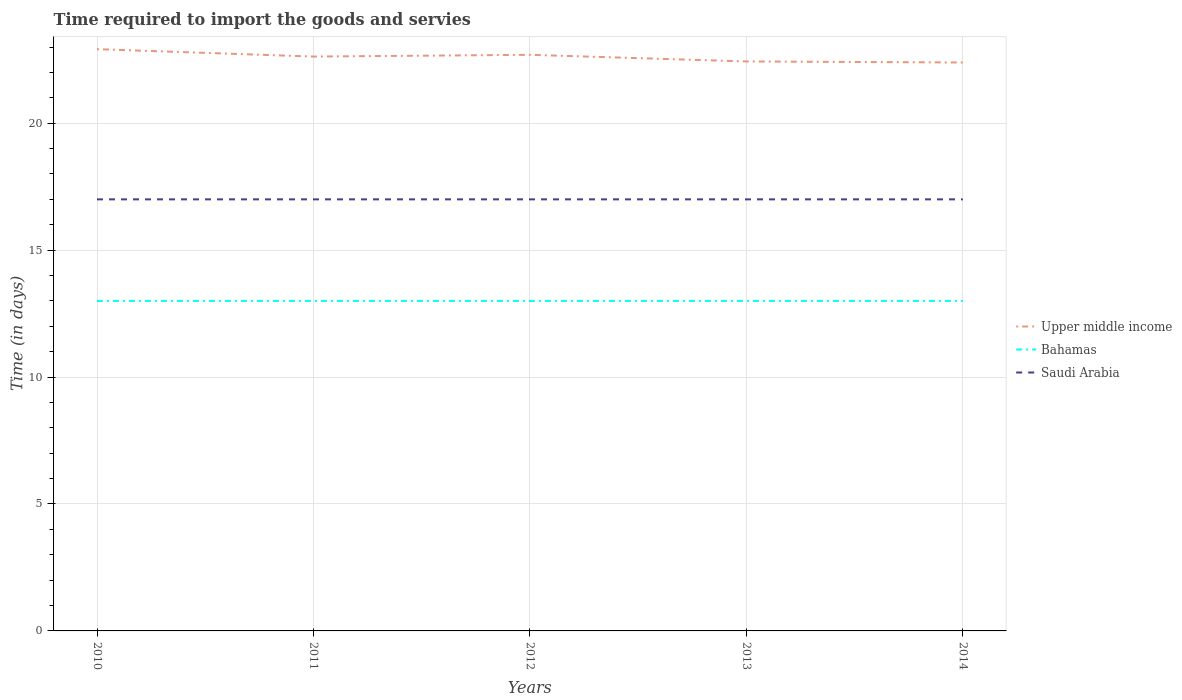Across all years, what is the maximum number of days required to import the goods and services in Upper middle income?
Your answer should be compact. 22.39. In which year was the number of days required to import the goods and services in Upper middle income maximum?
Provide a short and direct response. 2014. What is the difference between the highest and the lowest number of days required to import the goods and services in Saudi Arabia?
Offer a very short reply. 0. Does the graph contain grids?
Keep it short and to the point. Yes. Where does the legend appear in the graph?
Keep it short and to the point. Center right. How many legend labels are there?
Provide a succinct answer. 3. How are the legend labels stacked?
Offer a terse response. Vertical. What is the title of the graph?
Provide a short and direct response. Time required to import the goods and servies. Does "United Kingdom" appear as one of the legend labels in the graph?
Make the answer very short. No. What is the label or title of the Y-axis?
Make the answer very short. Time (in days). What is the Time (in days) of Upper middle income in 2010?
Provide a succinct answer. 22.92. What is the Time (in days) in Upper middle income in 2011?
Offer a very short reply. 22.62. What is the Time (in days) of Bahamas in 2011?
Keep it short and to the point. 13. What is the Time (in days) in Saudi Arabia in 2011?
Provide a succinct answer. 17. What is the Time (in days) of Upper middle income in 2012?
Provide a succinct answer. 22.69. What is the Time (in days) of Bahamas in 2012?
Offer a very short reply. 13. What is the Time (in days) in Saudi Arabia in 2012?
Give a very brief answer. 17. What is the Time (in days) in Upper middle income in 2013?
Keep it short and to the point. 22.43. What is the Time (in days) of Upper middle income in 2014?
Offer a terse response. 22.39. What is the Time (in days) of Saudi Arabia in 2014?
Give a very brief answer. 17. Across all years, what is the maximum Time (in days) in Upper middle income?
Give a very brief answer. 22.92. Across all years, what is the minimum Time (in days) in Upper middle income?
Your answer should be very brief. 22.39. Across all years, what is the minimum Time (in days) in Bahamas?
Provide a short and direct response. 13. Across all years, what is the minimum Time (in days) of Saudi Arabia?
Provide a short and direct response. 17. What is the total Time (in days) of Upper middle income in the graph?
Your response must be concise. 113.06. What is the difference between the Time (in days) of Upper middle income in 2010 and that in 2011?
Offer a terse response. 0.29. What is the difference between the Time (in days) in Saudi Arabia in 2010 and that in 2011?
Give a very brief answer. 0. What is the difference between the Time (in days) in Upper middle income in 2010 and that in 2012?
Your response must be concise. 0.22. What is the difference between the Time (in days) of Bahamas in 2010 and that in 2012?
Provide a short and direct response. 0. What is the difference between the Time (in days) in Saudi Arabia in 2010 and that in 2012?
Provide a short and direct response. 0. What is the difference between the Time (in days) in Upper middle income in 2010 and that in 2013?
Offer a terse response. 0.48. What is the difference between the Time (in days) in Bahamas in 2010 and that in 2013?
Your answer should be compact. 0. What is the difference between the Time (in days) in Saudi Arabia in 2010 and that in 2013?
Provide a short and direct response. 0. What is the difference between the Time (in days) of Upper middle income in 2010 and that in 2014?
Your response must be concise. 0.52. What is the difference between the Time (in days) in Bahamas in 2010 and that in 2014?
Offer a terse response. 0. What is the difference between the Time (in days) of Saudi Arabia in 2010 and that in 2014?
Make the answer very short. 0. What is the difference between the Time (in days) in Upper middle income in 2011 and that in 2012?
Provide a succinct answer. -0.07. What is the difference between the Time (in days) in Upper middle income in 2011 and that in 2013?
Keep it short and to the point. 0.19. What is the difference between the Time (in days) in Bahamas in 2011 and that in 2013?
Provide a succinct answer. 0. What is the difference between the Time (in days) of Upper middle income in 2011 and that in 2014?
Keep it short and to the point. 0.23. What is the difference between the Time (in days) of Saudi Arabia in 2011 and that in 2014?
Your answer should be compact. 0. What is the difference between the Time (in days) in Upper middle income in 2012 and that in 2013?
Ensure brevity in your answer.  0.26. What is the difference between the Time (in days) of Upper middle income in 2012 and that in 2014?
Offer a very short reply. 0.3. What is the difference between the Time (in days) of Bahamas in 2012 and that in 2014?
Make the answer very short. 0. What is the difference between the Time (in days) in Saudi Arabia in 2012 and that in 2014?
Make the answer very short. 0. What is the difference between the Time (in days) in Upper middle income in 2013 and that in 2014?
Your answer should be compact. 0.04. What is the difference between the Time (in days) in Bahamas in 2013 and that in 2014?
Ensure brevity in your answer.  0. What is the difference between the Time (in days) in Saudi Arabia in 2013 and that in 2014?
Ensure brevity in your answer.  0. What is the difference between the Time (in days) of Upper middle income in 2010 and the Time (in days) of Bahamas in 2011?
Give a very brief answer. 9.92. What is the difference between the Time (in days) of Upper middle income in 2010 and the Time (in days) of Saudi Arabia in 2011?
Your response must be concise. 5.92. What is the difference between the Time (in days) in Upper middle income in 2010 and the Time (in days) in Bahamas in 2012?
Offer a terse response. 9.92. What is the difference between the Time (in days) of Upper middle income in 2010 and the Time (in days) of Saudi Arabia in 2012?
Give a very brief answer. 5.92. What is the difference between the Time (in days) in Bahamas in 2010 and the Time (in days) in Saudi Arabia in 2012?
Make the answer very short. -4. What is the difference between the Time (in days) of Upper middle income in 2010 and the Time (in days) of Bahamas in 2013?
Your answer should be compact. 9.92. What is the difference between the Time (in days) of Upper middle income in 2010 and the Time (in days) of Saudi Arabia in 2013?
Your response must be concise. 5.92. What is the difference between the Time (in days) in Bahamas in 2010 and the Time (in days) in Saudi Arabia in 2013?
Offer a very short reply. -4. What is the difference between the Time (in days) in Upper middle income in 2010 and the Time (in days) in Bahamas in 2014?
Your answer should be compact. 9.92. What is the difference between the Time (in days) of Upper middle income in 2010 and the Time (in days) of Saudi Arabia in 2014?
Ensure brevity in your answer.  5.92. What is the difference between the Time (in days) of Upper middle income in 2011 and the Time (in days) of Bahamas in 2012?
Your answer should be compact. 9.62. What is the difference between the Time (in days) of Upper middle income in 2011 and the Time (in days) of Saudi Arabia in 2012?
Keep it short and to the point. 5.62. What is the difference between the Time (in days) of Upper middle income in 2011 and the Time (in days) of Bahamas in 2013?
Offer a terse response. 9.62. What is the difference between the Time (in days) of Upper middle income in 2011 and the Time (in days) of Saudi Arabia in 2013?
Your answer should be very brief. 5.62. What is the difference between the Time (in days) of Upper middle income in 2011 and the Time (in days) of Bahamas in 2014?
Provide a succinct answer. 9.62. What is the difference between the Time (in days) in Upper middle income in 2011 and the Time (in days) in Saudi Arabia in 2014?
Ensure brevity in your answer.  5.62. What is the difference between the Time (in days) of Bahamas in 2011 and the Time (in days) of Saudi Arabia in 2014?
Give a very brief answer. -4. What is the difference between the Time (in days) of Upper middle income in 2012 and the Time (in days) of Bahamas in 2013?
Give a very brief answer. 9.69. What is the difference between the Time (in days) of Upper middle income in 2012 and the Time (in days) of Saudi Arabia in 2013?
Ensure brevity in your answer.  5.69. What is the difference between the Time (in days) in Bahamas in 2012 and the Time (in days) in Saudi Arabia in 2013?
Offer a very short reply. -4. What is the difference between the Time (in days) in Upper middle income in 2012 and the Time (in days) in Bahamas in 2014?
Provide a succinct answer. 9.69. What is the difference between the Time (in days) of Upper middle income in 2012 and the Time (in days) of Saudi Arabia in 2014?
Your response must be concise. 5.69. What is the difference between the Time (in days) in Upper middle income in 2013 and the Time (in days) in Bahamas in 2014?
Offer a terse response. 9.43. What is the difference between the Time (in days) of Upper middle income in 2013 and the Time (in days) of Saudi Arabia in 2014?
Your response must be concise. 5.43. What is the average Time (in days) in Upper middle income per year?
Your response must be concise. 22.61. In the year 2010, what is the difference between the Time (in days) of Upper middle income and Time (in days) of Bahamas?
Provide a short and direct response. 9.92. In the year 2010, what is the difference between the Time (in days) of Upper middle income and Time (in days) of Saudi Arabia?
Provide a succinct answer. 5.92. In the year 2011, what is the difference between the Time (in days) in Upper middle income and Time (in days) in Bahamas?
Provide a succinct answer. 9.62. In the year 2011, what is the difference between the Time (in days) in Upper middle income and Time (in days) in Saudi Arabia?
Keep it short and to the point. 5.62. In the year 2012, what is the difference between the Time (in days) of Upper middle income and Time (in days) of Bahamas?
Offer a terse response. 9.69. In the year 2012, what is the difference between the Time (in days) in Upper middle income and Time (in days) in Saudi Arabia?
Provide a succinct answer. 5.69. In the year 2013, what is the difference between the Time (in days) in Upper middle income and Time (in days) in Bahamas?
Your answer should be compact. 9.43. In the year 2013, what is the difference between the Time (in days) in Upper middle income and Time (in days) in Saudi Arabia?
Make the answer very short. 5.43. In the year 2014, what is the difference between the Time (in days) in Upper middle income and Time (in days) in Bahamas?
Your answer should be compact. 9.39. In the year 2014, what is the difference between the Time (in days) of Upper middle income and Time (in days) of Saudi Arabia?
Give a very brief answer. 5.39. In the year 2014, what is the difference between the Time (in days) in Bahamas and Time (in days) in Saudi Arabia?
Provide a succinct answer. -4. What is the ratio of the Time (in days) in Upper middle income in 2010 to that in 2011?
Keep it short and to the point. 1.01. What is the ratio of the Time (in days) in Upper middle income in 2010 to that in 2012?
Offer a very short reply. 1.01. What is the ratio of the Time (in days) in Saudi Arabia in 2010 to that in 2012?
Make the answer very short. 1. What is the ratio of the Time (in days) of Upper middle income in 2010 to that in 2013?
Offer a very short reply. 1.02. What is the ratio of the Time (in days) in Upper middle income in 2010 to that in 2014?
Your answer should be compact. 1.02. What is the ratio of the Time (in days) in Bahamas in 2010 to that in 2014?
Keep it short and to the point. 1. What is the ratio of the Time (in days) in Saudi Arabia in 2010 to that in 2014?
Your response must be concise. 1. What is the ratio of the Time (in days) of Upper middle income in 2011 to that in 2013?
Your response must be concise. 1.01. What is the ratio of the Time (in days) in Upper middle income in 2011 to that in 2014?
Ensure brevity in your answer.  1.01. What is the ratio of the Time (in days) in Bahamas in 2011 to that in 2014?
Keep it short and to the point. 1. What is the ratio of the Time (in days) in Saudi Arabia in 2011 to that in 2014?
Offer a very short reply. 1. What is the ratio of the Time (in days) in Upper middle income in 2012 to that in 2013?
Offer a very short reply. 1.01. What is the ratio of the Time (in days) of Upper middle income in 2012 to that in 2014?
Offer a terse response. 1.01. What is the ratio of the Time (in days) in Bahamas in 2012 to that in 2014?
Your answer should be very brief. 1. What is the ratio of the Time (in days) in Upper middle income in 2013 to that in 2014?
Offer a very short reply. 1. What is the ratio of the Time (in days) of Saudi Arabia in 2013 to that in 2014?
Give a very brief answer. 1. What is the difference between the highest and the second highest Time (in days) in Upper middle income?
Provide a succinct answer. 0.22. What is the difference between the highest and the second highest Time (in days) in Bahamas?
Ensure brevity in your answer.  0. What is the difference between the highest and the lowest Time (in days) in Upper middle income?
Your answer should be very brief. 0.52. What is the difference between the highest and the lowest Time (in days) in Saudi Arabia?
Offer a very short reply. 0. 